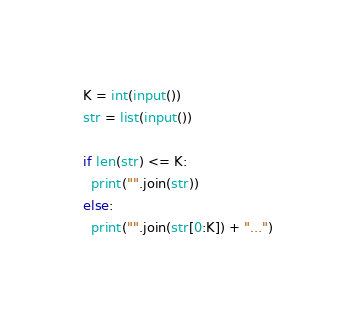Convert code to text. <code><loc_0><loc_0><loc_500><loc_500><_Python_>K = int(input())
str = list(input())
 
if len(str) <= K:
  print("".join(str))
else:
  print("".join(str[0:K]) + "...")</code> 